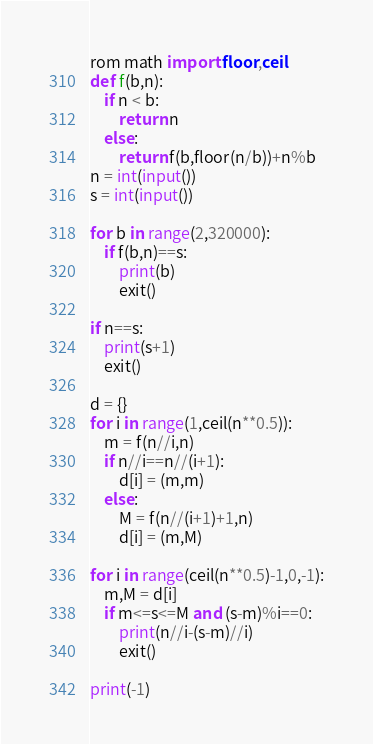Convert code to text. <code><loc_0><loc_0><loc_500><loc_500><_Python_>rom math import floor,ceil
def f(b,n):
    if n < b:
        return n
    else:
        return f(b,floor(n/b))+n%b
n = int(input())
s = int(input())

for b in range(2,320000):
    if f(b,n)==s:
        print(b)
        exit()

if n==s:
    print(s+1)
    exit()

d = {}
for i in range(1,ceil(n**0.5)):
    m = f(n//i,n)
    if n//i==n//(i+1):
        d[i] = (m,m)
    else:
        M = f(n//(i+1)+1,n)
        d[i] = (m,M)

for i in range(ceil(n**0.5)-1,0,-1):
    m,M = d[i]
    if m<=s<=M and (s-m)%i==0:
        print(n//i-(s-m)//i)
        exit()

print(-1)</code> 